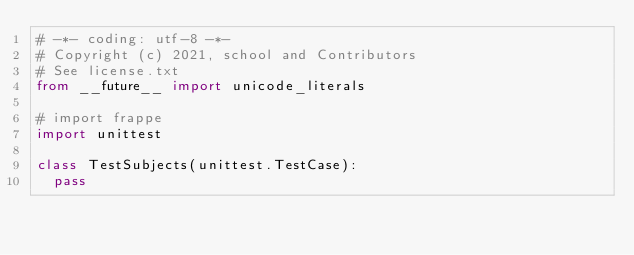Convert code to text. <code><loc_0><loc_0><loc_500><loc_500><_Python_># -*- coding: utf-8 -*-
# Copyright (c) 2021, school and Contributors
# See license.txt
from __future__ import unicode_literals

# import frappe
import unittest

class TestSubjects(unittest.TestCase):
	pass
</code> 